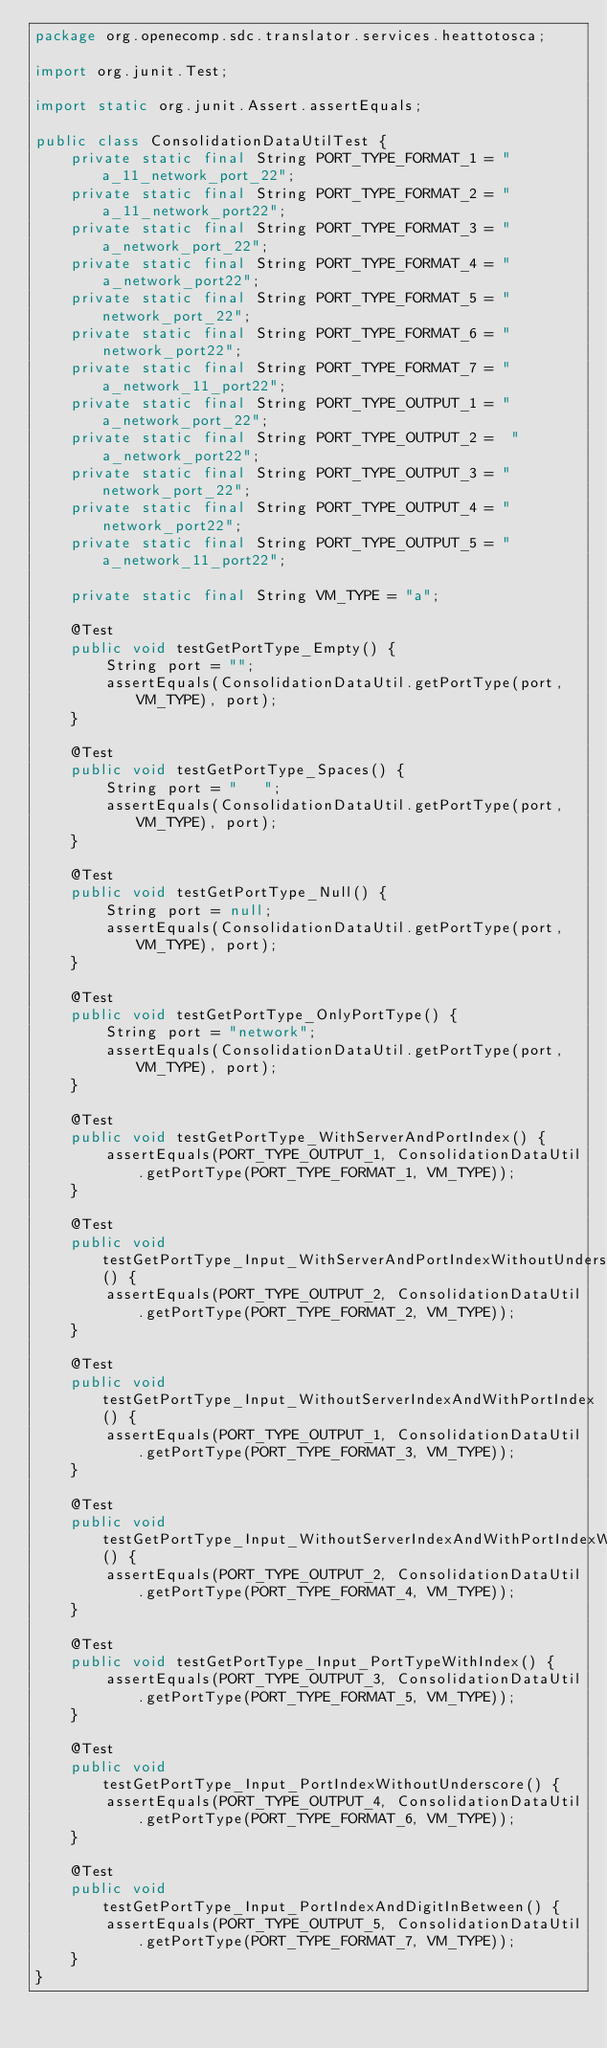Convert code to text. <code><loc_0><loc_0><loc_500><loc_500><_Java_>package org.openecomp.sdc.translator.services.heattotosca;

import org.junit.Test;

import static org.junit.Assert.assertEquals;

public class ConsolidationDataUtilTest {
    private static final String PORT_TYPE_FORMAT_1 = "a_11_network_port_22";
    private static final String PORT_TYPE_FORMAT_2 = "a_11_network_port22";
    private static final String PORT_TYPE_FORMAT_3 = "a_network_port_22";
    private static final String PORT_TYPE_FORMAT_4 = "a_network_port22";
    private static final String PORT_TYPE_FORMAT_5 = "network_port_22";
    private static final String PORT_TYPE_FORMAT_6 = "network_port22";
    private static final String PORT_TYPE_FORMAT_7 = "a_network_11_port22";
    private static final String PORT_TYPE_OUTPUT_1 = "a_network_port_22";
    private static final String PORT_TYPE_OUTPUT_2 =  "a_network_port22";
    private static final String PORT_TYPE_OUTPUT_3 = "network_port_22";
    private static final String PORT_TYPE_OUTPUT_4 = "network_port22";
    private static final String PORT_TYPE_OUTPUT_5 = "a_network_11_port22";

    private static final String VM_TYPE = "a";

    @Test
    public void testGetPortType_Empty() {
        String port = "";
        assertEquals(ConsolidationDataUtil.getPortType(port, VM_TYPE), port);
    }

    @Test
    public void testGetPortType_Spaces() {
        String port = "   ";
        assertEquals(ConsolidationDataUtil.getPortType(port, VM_TYPE), port);
    }

    @Test
    public void testGetPortType_Null() {
        String port = null;
        assertEquals(ConsolidationDataUtil.getPortType(port, VM_TYPE), port);
    }

    @Test
    public void testGetPortType_OnlyPortType() {
        String port = "network";
        assertEquals(ConsolidationDataUtil.getPortType(port, VM_TYPE), port);
    }

    @Test
    public void testGetPortType_WithServerAndPortIndex() {
        assertEquals(PORT_TYPE_OUTPUT_1, ConsolidationDataUtil.getPortType(PORT_TYPE_FORMAT_1, VM_TYPE));
    }

    @Test
    public void testGetPortType_Input_WithServerAndPortIndexWithoutUnderscore() {
        assertEquals(PORT_TYPE_OUTPUT_2, ConsolidationDataUtil.getPortType(PORT_TYPE_FORMAT_2, VM_TYPE));
    }

    @Test
    public void testGetPortType_Input_WithoutServerIndexAndWithPortIndex() {
        assertEquals(PORT_TYPE_OUTPUT_1, ConsolidationDataUtil.getPortType(PORT_TYPE_FORMAT_3, VM_TYPE));
    }

    @Test
    public void testGetPortType_Input_WithoutServerIndexAndWithPortIndexWithoutUnderscore() {
        assertEquals(PORT_TYPE_OUTPUT_2, ConsolidationDataUtil.getPortType(PORT_TYPE_FORMAT_4, VM_TYPE));
    }

    @Test
    public void testGetPortType_Input_PortTypeWithIndex() {
        assertEquals(PORT_TYPE_OUTPUT_3, ConsolidationDataUtil.getPortType(PORT_TYPE_FORMAT_5, VM_TYPE));
    }

    @Test
    public void testGetPortType_Input_PortIndexWithoutUnderscore() {
        assertEquals(PORT_TYPE_OUTPUT_4, ConsolidationDataUtil.getPortType(PORT_TYPE_FORMAT_6, VM_TYPE));
    }

    @Test
    public void testGetPortType_Input_PortIndexAndDigitInBetween() {
        assertEquals(PORT_TYPE_OUTPUT_5, ConsolidationDataUtil.getPortType(PORT_TYPE_FORMAT_7, VM_TYPE));
    }
}
</code> 